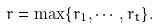<formula> <loc_0><loc_0><loc_500><loc_500>r = \max \{ r _ { 1 } , \cdots , r _ { t } \} .</formula> 